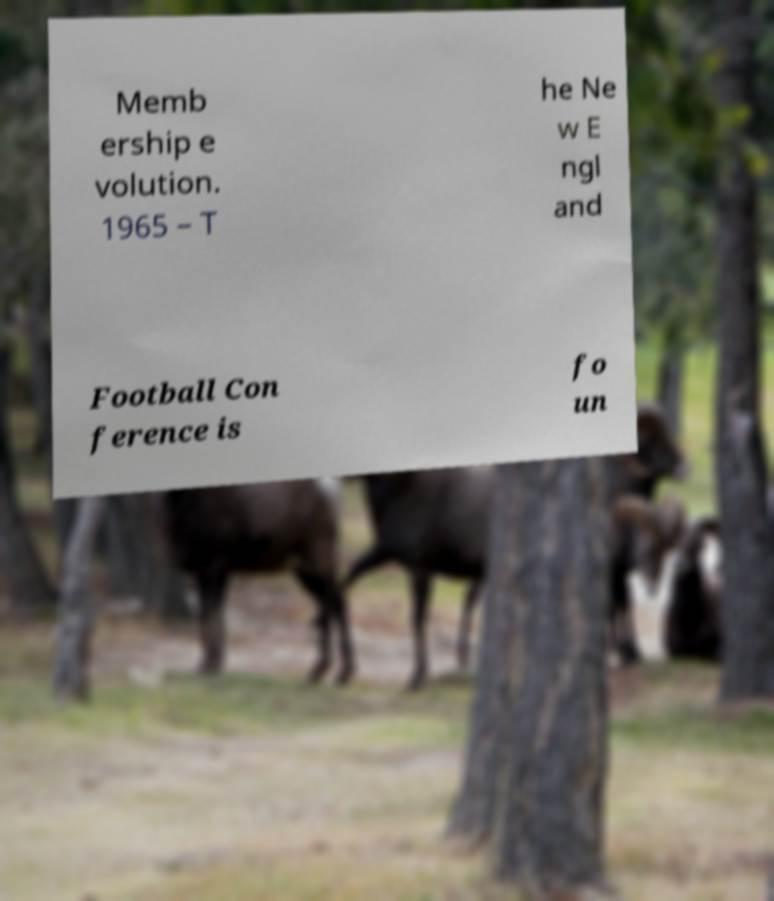Please identify and transcribe the text found in this image. Memb ership e volution. 1965 – T he Ne w E ngl and Football Con ference is fo un 